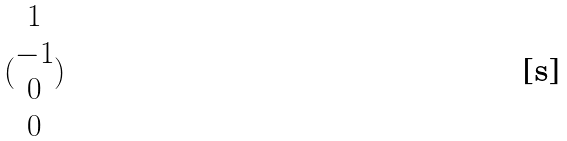Convert formula to latex. <formula><loc_0><loc_0><loc_500><loc_500>( \begin{matrix} 1 \\ - 1 \\ 0 \\ 0 \end{matrix} )</formula> 